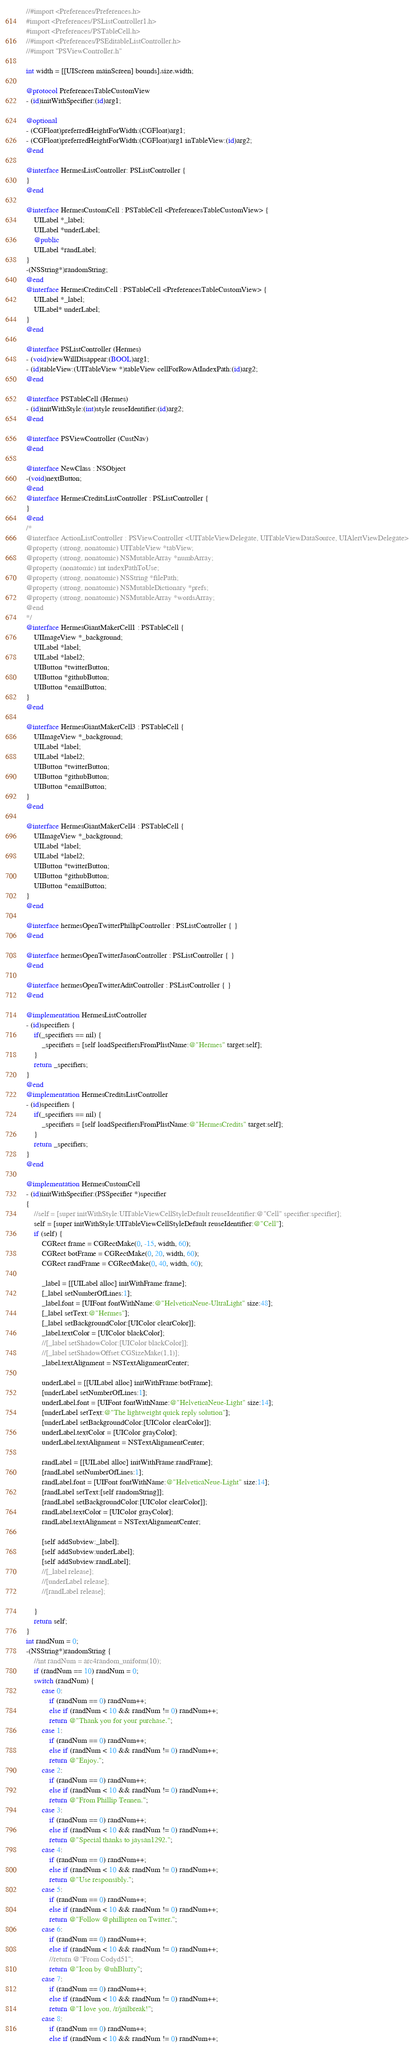Convert code to text. <code><loc_0><loc_0><loc_500><loc_500><_ObjectiveC_>//#import <Preferences/Preferences.h>
#import <Preferences/PSListController1.h>
#import <Preferences/PSTableCell.h>
//#import <Preferences/PSEditableListController.h>
//#import "PSViewController.h"

int width = [[UIScreen mainScreen] bounds].size.width;

@protocol PreferencesTableCustomView
- (id)initWithSpecifier:(id)arg1;

@optional
- (CGFloat)preferredHeightForWidth:(CGFloat)arg1;
- (CGFloat)preferredHeightForWidth:(CGFloat)arg1 inTableView:(id)arg2;
@end

@interface HermesListController: PSListController {
}
@end

@interface HermesCustomCell : PSTableCell <PreferencesTableCustomView> {
	UILabel *_label;
	UILabel *underLabel;
	@public
	UILabel *randLabel;
}
-(NSString*)randomString;
@end
@interface HermesCreditsCell : PSTableCell <PreferencesTableCustomView> {
	UILabel *_label;
	UILabel* underLabel;
}
@end

@interface PSListController (Hermes)
- (void)viewWillDisappear:(BOOL)arg1;
- (id)tableView:(UITableView *)tableView cellForRowAtIndexPath:(id)arg2;
@end

@interface PSTableCell (Hermes)
- (id)initWithStyle:(int)style reuseIdentifier:(id)arg2;
@end

@interface PSViewController (CustNav)
@end

@interface NewClass : NSObject
-(void)nextButton;
@end
@interface HermesCreditsListController : PSListController {
}
@end
/*
@interface ActionListController : PSViewController <UITableViewDelegate, UITableViewDataSource, UIAlertViewDelegate>
@property (strong, nonatomic) UITableView *tabView;
@property (strong, nonatomic) NSMutableArray *numbArray;
@property (nonatomic) int indexPathToUse;
@property (strong, nonatomic) NSString *filePath;
@property (strong, nonatomic) NSMutableDictionary *prefs;
@property (strong, nonatomic) NSMutableArray *wordsArray;
@end
*/
@interface HermesGiantMakerCell1 : PSTableCell {
	UIImageView *_background;
	UILabel *label;
	UILabel *label2;
	UIButton *twitterButton;
	UIButton *githubButton;
	UIButton *emailButton;
}
@end

@interface HermesGiantMakerCell3 : PSTableCell {
	UIImageView *_background;
	UILabel *label;
	UILabel *label2;
	UIButton *twitterButton;
	UIButton *githubButton;
	UIButton *emailButton;
}
@end

@interface HermesGiantMakerCell4 : PSTableCell {
	UIImageView *_background;
	UILabel *label;
	UILabel *label2;
	UIButton *twitterButton;
	UIButton *githubButton;
	UIButton *emailButton;
}
@end

@interface hermesOpenTwitterPhillipController : PSListController { }
@end

@interface hermesOpenTwitterJasonController : PSListController { }
@end

@interface hermesOpenTwitterAditController : PSListController { }
@end

@implementation HermesListController
- (id)specifiers {
	if(_specifiers == nil) {
		_specifiers = [self loadSpecifiersFromPlistName:@"Hermes" target:self];
	}
	return _specifiers;
}
@end
@implementation HermesCreditsListController
- (id)specifiers {
	if(_specifiers == nil) {
		_specifiers = [self loadSpecifiersFromPlistName:@"HermesCredits" target:self];
	}
	return _specifiers;
}
@end

@implementation HermesCustomCell
- (id)initWithSpecifier:(PSSpecifier *)specifier
{
	//self = [super initWithStyle:UITableViewCellStyleDefault reuseIdentifier:@"Cell" specifier:specifier];
	self = [super initWithStyle:UITableViewCellStyleDefault reuseIdentifier:@"Cell"];
	if (self) {
		CGRect frame = CGRectMake(0, -15, width, 60);
		CGRect botFrame = CGRectMake(0, 20, width, 60);
		CGRect randFrame = CGRectMake(0, 40, width, 60);
 
		_label = [[UILabel alloc] initWithFrame:frame];
		[_label setNumberOfLines:1];
		_label.font = [UIFont fontWithName:@"HelveticaNeue-UltraLight" size:48];
		[_label setText:@"Hermes"];
		[_label setBackgroundColor:[UIColor clearColor]];
		_label.textColor = [UIColor blackColor];
		//[_label setShadowColor:[UIColor blackColor]];
		//[_label setShadowOffset:CGSizeMake(1,1)];
		_label.textAlignment = NSTextAlignmentCenter;

		underLabel = [[UILabel alloc] initWithFrame:botFrame];
		[underLabel setNumberOfLines:1];
		underLabel.font = [UIFont fontWithName:@"HelveticaNeue-Light" size:14];
		[underLabel setText:@"The lightweight quick reply solution"];
		[underLabel setBackgroundColor:[UIColor clearColor]];
		underLabel.textColor = [UIColor grayColor];
		underLabel.textAlignment = NSTextAlignmentCenter;

		randLabel = [[UILabel alloc] initWithFrame:randFrame];
		[randLabel setNumberOfLines:1];
		randLabel.font = [UIFont fontWithName:@"HelveticaNeue-Light" size:14];
		[randLabel setText:[self randomString]];
		[randLabel setBackgroundColor:[UIColor clearColor]];
		randLabel.textColor = [UIColor grayColor];
		randLabel.textAlignment = NSTextAlignmentCenter;
 
		[self addSubview:_label];
		[self addSubview:underLabel];
		[self addSubview:randLabel];
		//[_label release];
		//[underLabel release];
		//[randLabel release];

	}
	return self;
}
int randNum = 0;
-(NSString*)randomString {
	//int randNum = arc4random_uniform(10);
	if (randNum == 10) randNum = 0;
	switch (randNum) {
		case 0:
			if (randNum == 0) randNum++;
			else if (randNum < 10 && randNum != 0) randNum++;
			return @"Thank you for your purchase.";
		case 1:
			if (randNum == 0) randNum++;
			else if (randNum < 10 && randNum != 0) randNum++;
			return @"Enjoy.";
		case 2:
			if (randNum == 0) randNum++;
			else if (randNum < 10 && randNum != 0) randNum++;
			return @"From Phillip Tennen.";
		case 3:
			if (randNum == 0) randNum++;
			else if (randNum < 10 && randNum != 0) randNum++;
			return @"Special thanks to jaysan1292.";
		case 4:
			if (randNum == 0) randNum++;
			else if (randNum < 10 && randNum != 0) randNum++;
			return @"Use responsibly.";
		case 5:
			if (randNum == 0) randNum++;
			else if (randNum < 10 && randNum != 0) randNum++;
			return @"Follow @phillipten on Twitter.";
		case 6:
			if (randNum == 0) randNum++;
			else if (randNum < 10 && randNum != 0) randNum++;
			//return @"From Codyd51";
			return @"Icon by @uhBlurry";
		case 7:
			if (randNum == 0) randNum++;
			else if (randNum < 10 && randNum != 0) randNum++;
			return @"I love you, /r/jailbreak!";
		case 8:
			if (randNum == 0) randNum++;
			else if (randNum < 10 && randNum != 0) randNum++;</code> 